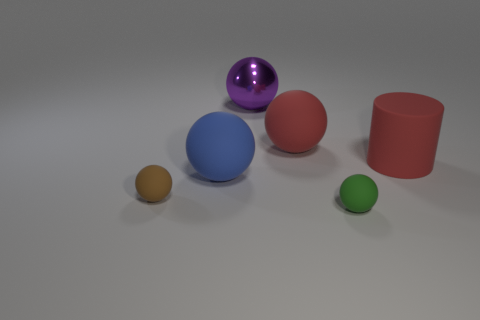Subtract 2 spheres. How many spheres are left? 3 Subtract all blue spheres. How many spheres are left? 4 Subtract all cyan balls. Subtract all gray cylinders. How many balls are left? 5 Add 4 large cyan rubber objects. How many objects exist? 10 Subtract all spheres. How many objects are left? 1 Add 5 big red rubber spheres. How many big red rubber spheres are left? 6 Add 4 tiny blue matte cylinders. How many tiny blue matte cylinders exist? 4 Subtract 0 gray spheres. How many objects are left? 6 Subtract all tiny cyan metallic spheres. Subtract all brown rubber things. How many objects are left? 5 